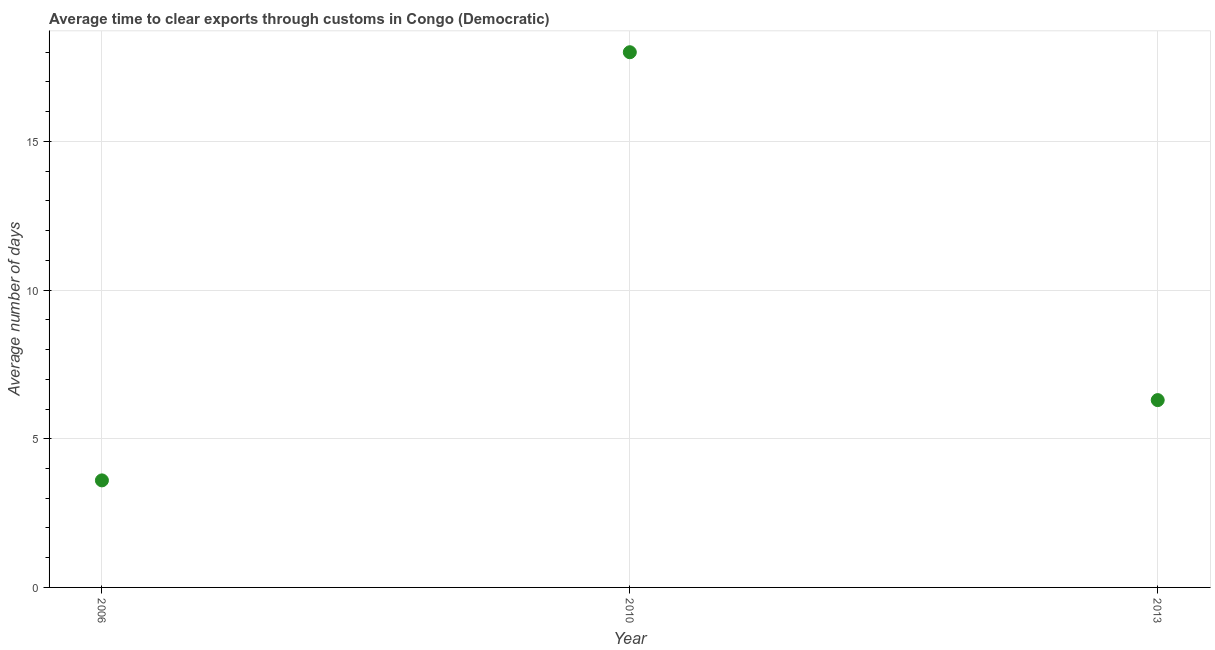In which year was the time to clear exports through customs maximum?
Provide a succinct answer. 2010. In which year was the time to clear exports through customs minimum?
Your answer should be very brief. 2006. What is the sum of the time to clear exports through customs?
Your response must be concise. 27.9. What is the median time to clear exports through customs?
Keep it short and to the point. 6.3. In how many years, is the time to clear exports through customs greater than 17 days?
Provide a succinct answer. 1. Do a majority of the years between 2006 and 2010 (inclusive) have time to clear exports through customs greater than 1 days?
Make the answer very short. Yes. What is the ratio of the time to clear exports through customs in 2006 to that in 2013?
Make the answer very short. 0.57. What is the difference between the highest and the second highest time to clear exports through customs?
Your response must be concise. 11.7. Is the sum of the time to clear exports through customs in 2006 and 2013 greater than the maximum time to clear exports through customs across all years?
Offer a terse response. No. What is the difference between the highest and the lowest time to clear exports through customs?
Offer a very short reply. 14.4. In how many years, is the time to clear exports through customs greater than the average time to clear exports through customs taken over all years?
Make the answer very short. 1. Does the time to clear exports through customs monotonically increase over the years?
Ensure brevity in your answer.  No. How many dotlines are there?
Provide a short and direct response. 1. How many years are there in the graph?
Give a very brief answer. 3. What is the difference between two consecutive major ticks on the Y-axis?
Give a very brief answer. 5. Does the graph contain grids?
Offer a very short reply. Yes. What is the title of the graph?
Make the answer very short. Average time to clear exports through customs in Congo (Democratic). What is the label or title of the X-axis?
Provide a short and direct response. Year. What is the label or title of the Y-axis?
Make the answer very short. Average number of days. What is the Average number of days in 2010?
Your response must be concise. 18. What is the difference between the Average number of days in 2006 and 2010?
Make the answer very short. -14.4. What is the ratio of the Average number of days in 2006 to that in 2010?
Offer a terse response. 0.2. What is the ratio of the Average number of days in 2006 to that in 2013?
Offer a terse response. 0.57. What is the ratio of the Average number of days in 2010 to that in 2013?
Your response must be concise. 2.86. 